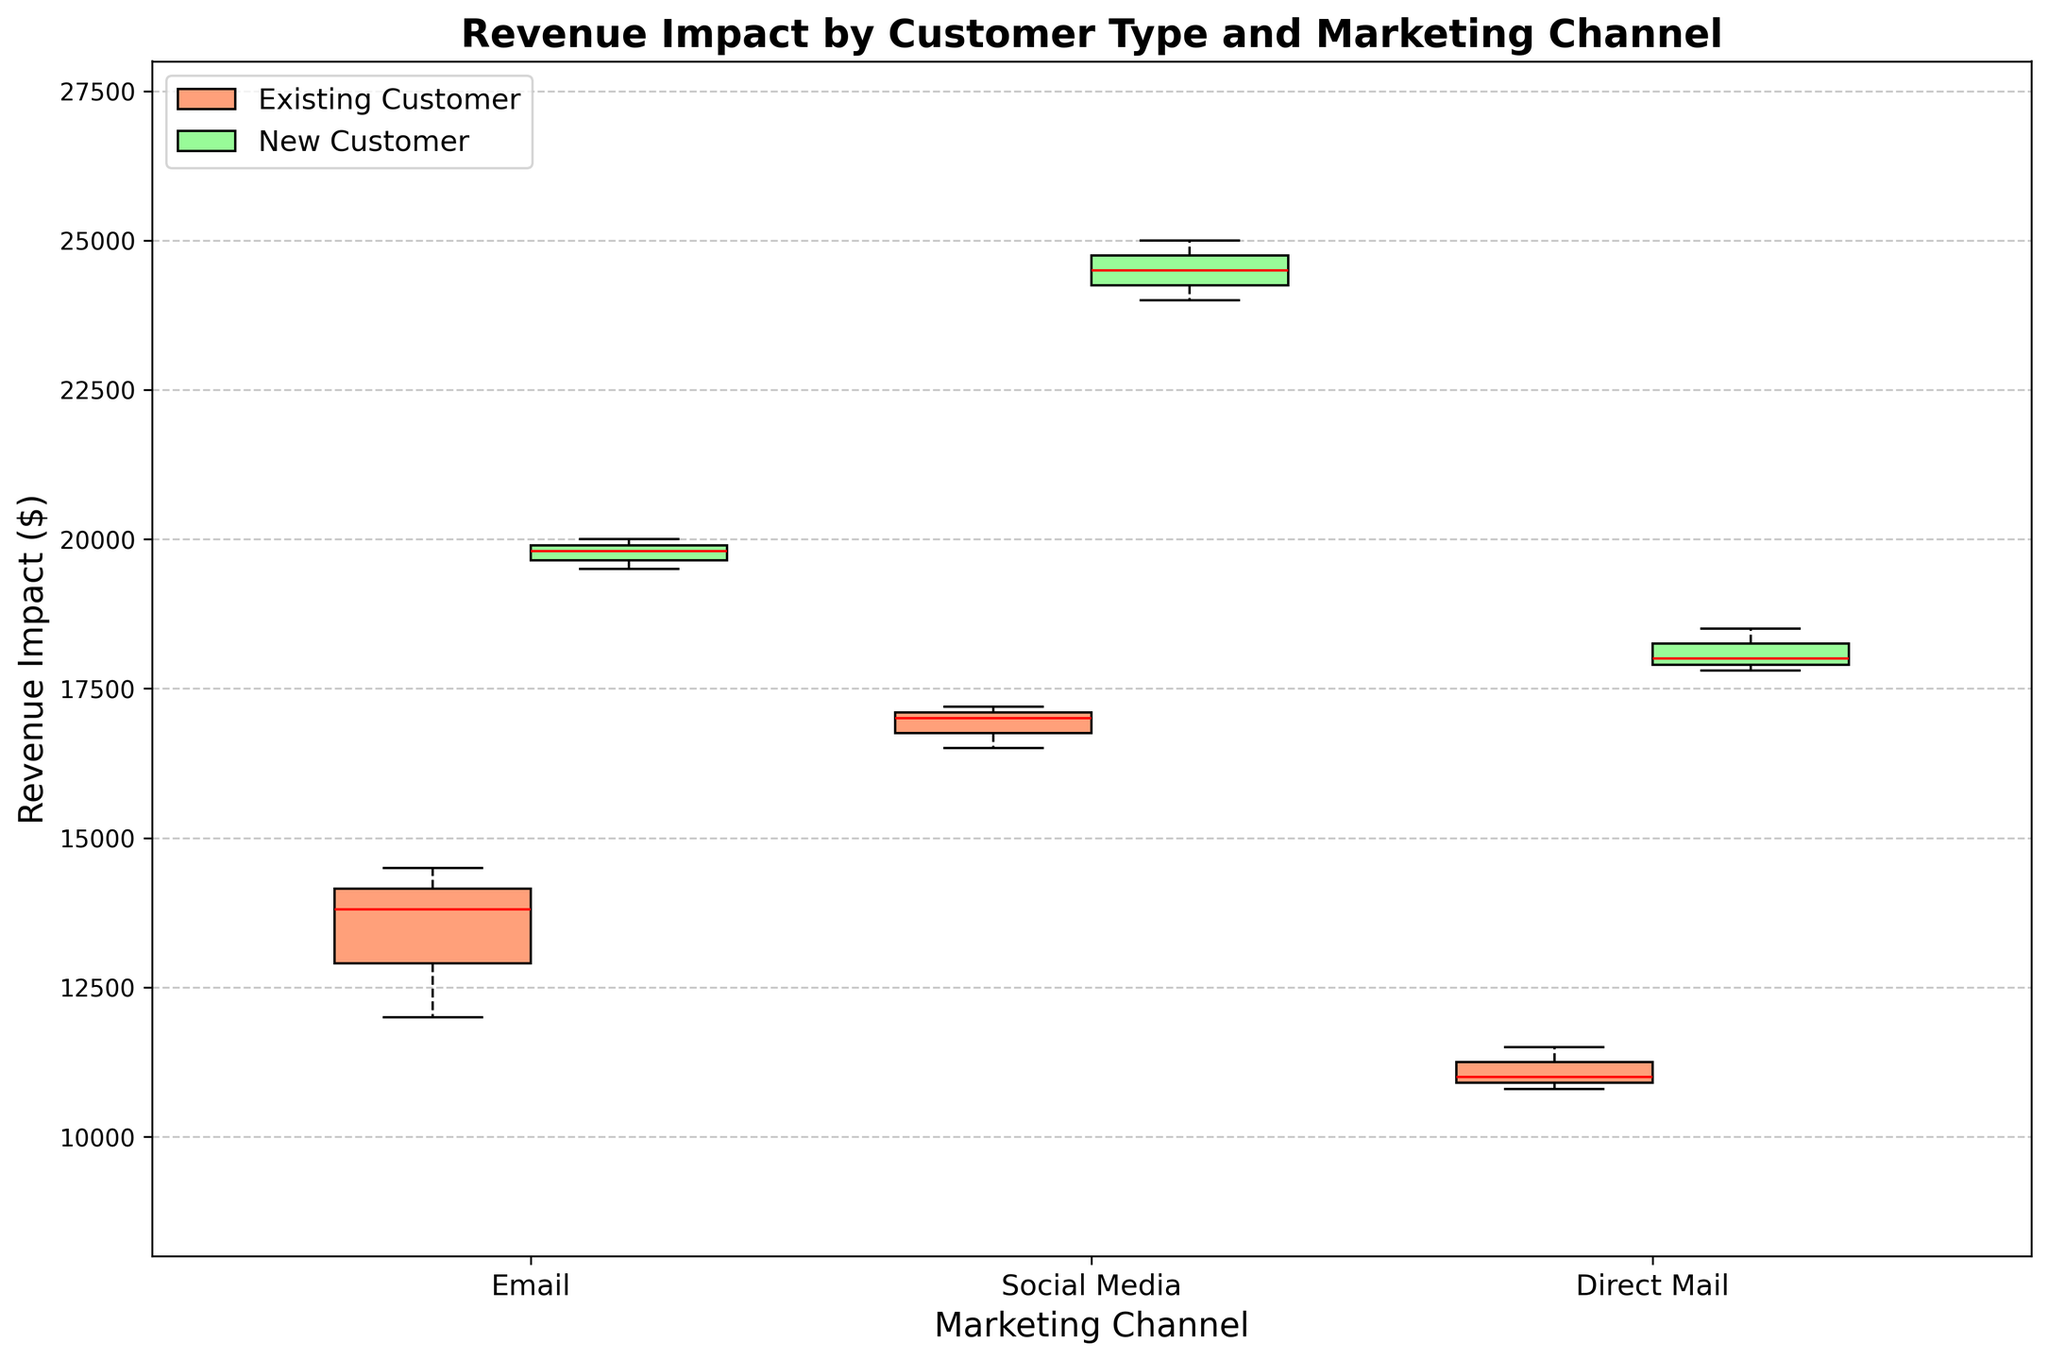What is the title of the plot? The title is usually displayed at the top of the plot and provides information about what the plot is showing. Here, the title indicates that the plot is comparing revenue impact across different customer types and marketing channels.
Answer: Revenue Impact by Customer Type and Marketing Channel What are the three marketing channels displayed on the x-axis? The x-axis in the plot is labeled 'Marketing Channel', and it includes three categories that represent different types of marketing efforts.
Answer: Email, Social Media, Direct Mail Which customer type shows a higher median revenue impact for the 'Email' marketing channel? To determine which customer type has the higher median revenue impact, look at the position of the median line within the box for both customer types under the 'Email' marketing channel. The box with the median line at a higher value indicates the higher median revenue impact.
Answer: New Customer How much revenue impact does the median value represent for 'Social Media' marketing channel among existing customers? For existing customers, find the median line within the 'Social Media' box. This line represents the midpoint of the revenue impact data.
Answer: 17000 Which marketing channel has the smallest range of revenue impact for new customers? The range of revenue impact can be determined by the distance between the top and bottom whiskers (the highest and lowest data points) of each box plot. The channel with the shortest whisker distance for new customers indicates the smallest range.
Answer: Direct Mail Between existing and new customers, which group has a higher maximum revenue impact for 'Social Media' marketing channel? The maximum revenue impact is shown by the top whisker of the box plot. Compare the top whiskers of both existing and new customers' boxes for 'Social Media' to see which one reaches higher.
Answer: New Customer How do the means of the revenue impacts compare between new and existing customers for the 'Direct Mail' marketing channel? The mean can be estimated by looking at the overall placement of the entire box plot (center of the box) and the distribution of whiskers. Compare the mean position for both groups under the 'Direct Mail' marketing channel.
Answer: New Customer likely higher What can you infer about the consistency of revenue impact in 'Email' marketing for new customers compared to existing customers? Consistency is inferred by the length of the box plot and whiskers. A shorter length implies less variation and more consistency. Compare the box plots and whiskers' lengths for new and existing customers under 'Email'.
Answer: New Customers more consistent Which group has a lower interquartile range (IQR) for the 'Social Media' marketing channel, existing or new customers? The IQR is represented by the length of the box (from the lower quartile to the upper quartile). Compare the lengths of the boxes for both groups under the 'Social Media' channel.
Answer: Existing Customer Adding all the median values for each marketing channel, which customer type has the higher total median revenue impact? The medians can be directly observed as the central line inside each box. Sum the medians of each channel for both existing and new customers to see which total is higher. For Existing Customers: Email (13800) + Social Media (17000) + Direct Mail (11000) = 41800. For New Customers: Email (19800) + Social Media (24500) + Direct Mail (18500) = 62800.
Answer: New Customer 